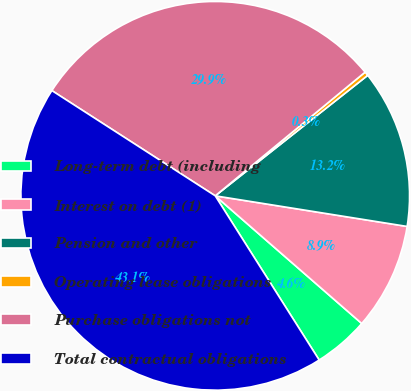Convert chart to OTSL. <chart><loc_0><loc_0><loc_500><loc_500><pie_chart><fcel>Long-term debt (including<fcel>Interest on debt (1)<fcel>Pension and other<fcel>Operating lease obligations<fcel>Purchase obligations not<fcel>Total contractual obligations<nl><fcel>4.61%<fcel>8.89%<fcel>13.16%<fcel>0.34%<fcel>29.91%<fcel>43.09%<nl></chart> 